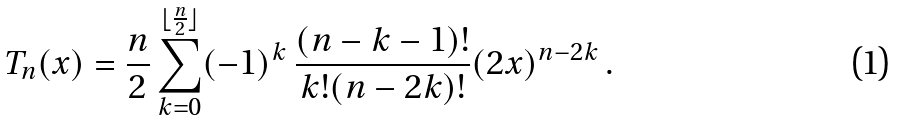Convert formula to latex. <formula><loc_0><loc_0><loc_500><loc_500>T _ { n } ( x ) = \frac { n } { 2 } \sum _ { k = 0 } ^ { \lfloor \frac { n } { 2 } \rfloor } ( - 1 ) ^ { k } \, \frac { ( n - k - 1 ) ! } { k ! ( n - 2 k ) ! } ( 2 x ) ^ { n - 2 k } \, .</formula> 